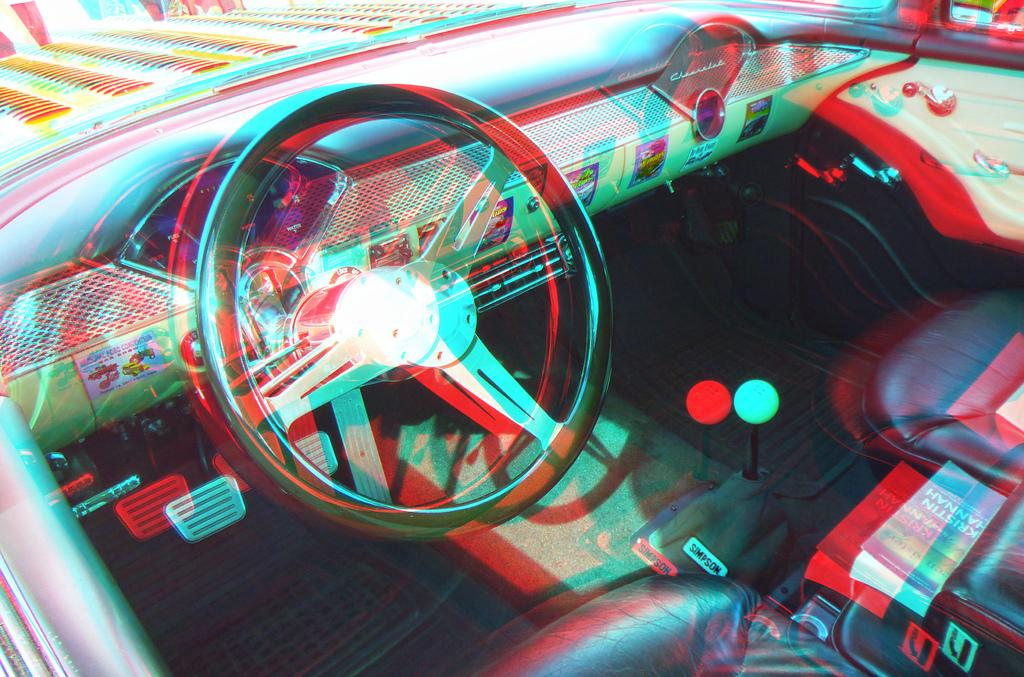What is the main focus of the image? The main focus of the image is the steering of a vehicle. What else can be seen in the image related to the vehicle? The dashboard of the vehicle is also visible in the image. Are there any other elements in the image related to the vehicle's interior? Yes, there are seats visible in the image. What non-vehicle-related item can be seen in the image? There is a book present in the image. How long does it take for the vehicle to cough in the image? There is no indication of the vehicle coughing in the image, as vehicles do not have the ability to cough. 